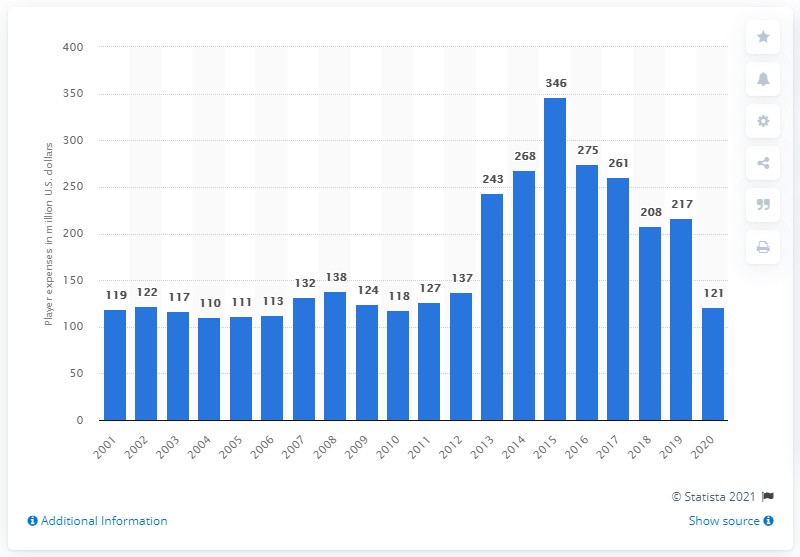List a handful of essential elements in this visual. The Dodgers' payroll in 2020 was approximately $121 million in dollars. 